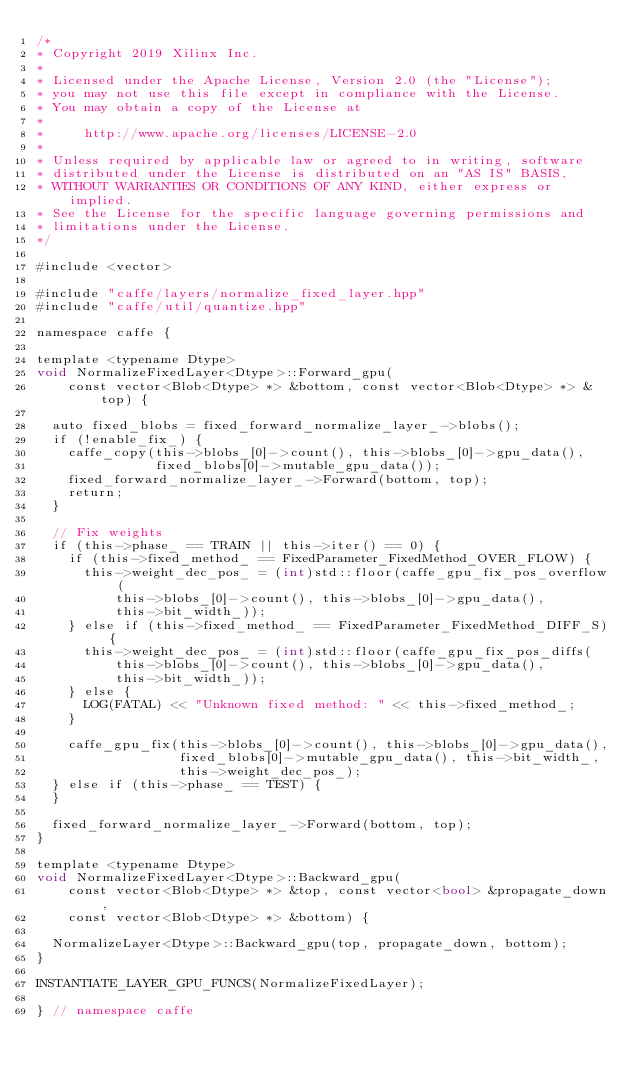Convert code to text. <code><loc_0><loc_0><loc_500><loc_500><_Cuda_>/*
* Copyright 2019 Xilinx Inc.
*
* Licensed under the Apache License, Version 2.0 (the "License");
* you may not use this file except in compliance with the License.
* You may obtain a copy of the License at
*
*     http://www.apache.org/licenses/LICENSE-2.0
*
* Unless required by applicable law or agreed to in writing, software
* distributed under the License is distributed on an "AS IS" BASIS,
* WITHOUT WARRANTIES OR CONDITIONS OF ANY KIND, either express or implied.
* See the License for the specific language governing permissions and
* limitations under the License.
*/

#include <vector>

#include "caffe/layers/normalize_fixed_layer.hpp"
#include "caffe/util/quantize.hpp"

namespace caffe {

template <typename Dtype>
void NormalizeFixedLayer<Dtype>::Forward_gpu(
    const vector<Blob<Dtype> *> &bottom, const vector<Blob<Dtype> *> &top) {

  auto fixed_blobs = fixed_forward_normalize_layer_->blobs();
  if (!enable_fix_) {
    caffe_copy(this->blobs_[0]->count(), this->blobs_[0]->gpu_data(),
               fixed_blobs[0]->mutable_gpu_data());
    fixed_forward_normalize_layer_->Forward(bottom, top);
    return;
  }

  // Fix weights
  if (this->phase_ == TRAIN || this->iter() == 0) {
    if (this->fixed_method_ == FixedParameter_FixedMethod_OVER_FLOW) {
      this->weight_dec_pos_ = (int)std::floor(caffe_gpu_fix_pos_overflow(
          this->blobs_[0]->count(), this->blobs_[0]->gpu_data(),
          this->bit_width_));
    } else if (this->fixed_method_ == FixedParameter_FixedMethod_DIFF_S) {
      this->weight_dec_pos_ = (int)std::floor(caffe_gpu_fix_pos_diffs(
          this->blobs_[0]->count(), this->blobs_[0]->gpu_data(),
          this->bit_width_));
    } else {
      LOG(FATAL) << "Unknown fixed method: " << this->fixed_method_;
    }

    caffe_gpu_fix(this->blobs_[0]->count(), this->blobs_[0]->gpu_data(),
                  fixed_blobs[0]->mutable_gpu_data(), this->bit_width_,
                  this->weight_dec_pos_);
  } else if (this->phase_ == TEST) {
  }

  fixed_forward_normalize_layer_->Forward(bottom, top);
}

template <typename Dtype>
void NormalizeFixedLayer<Dtype>::Backward_gpu(
    const vector<Blob<Dtype> *> &top, const vector<bool> &propagate_down,
    const vector<Blob<Dtype> *> &bottom) {

  NormalizeLayer<Dtype>::Backward_gpu(top, propagate_down, bottom);
}

INSTANTIATE_LAYER_GPU_FUNCS(NormalizeFixedLayer);

} // namespace caffe
</code> 